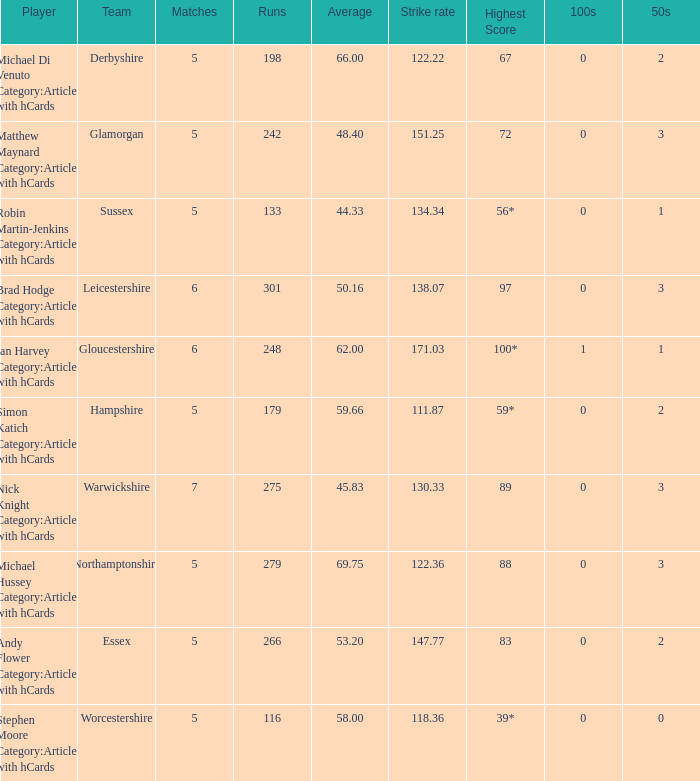What is the smallest amount of matches? 5.0. 